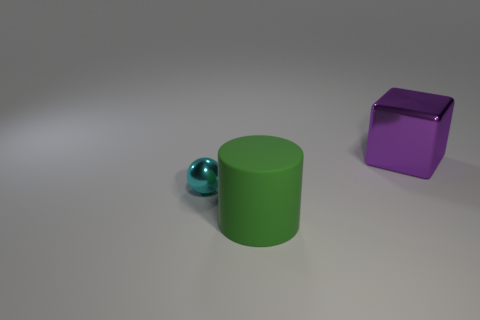How do the textures of the objects compare to one another? The green cylinder and the blue sphere have smooth and perhaps shiny textures, indicating a reflective surface that might be metallic or plastic in nature. The purple cube, however, appears to have a slightly matte texture indicating a different material, possibly a type of opaque plastic or painted surface. 